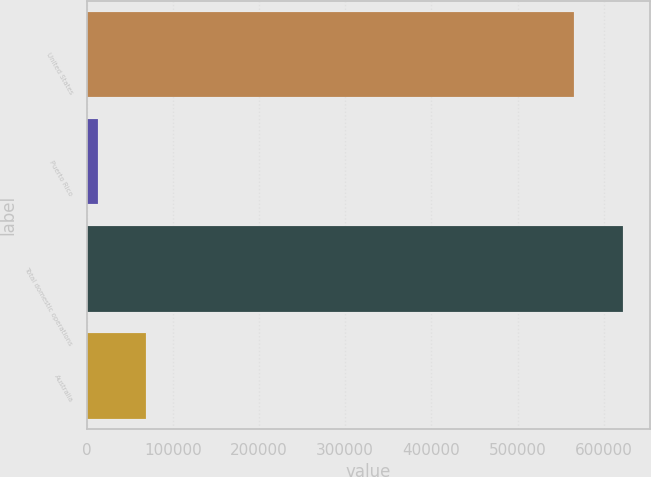Convert chart. <chart><loc_0><loc_0><loc_500><loc_500><bar_chart><fcel>United States<fcel>Puerto Rico<fcel>Total domestic operations<fcel>Australia<nl><fcel>565879<fcel>12746<fcel>622467<fcel>69333.9<nl></chart> 